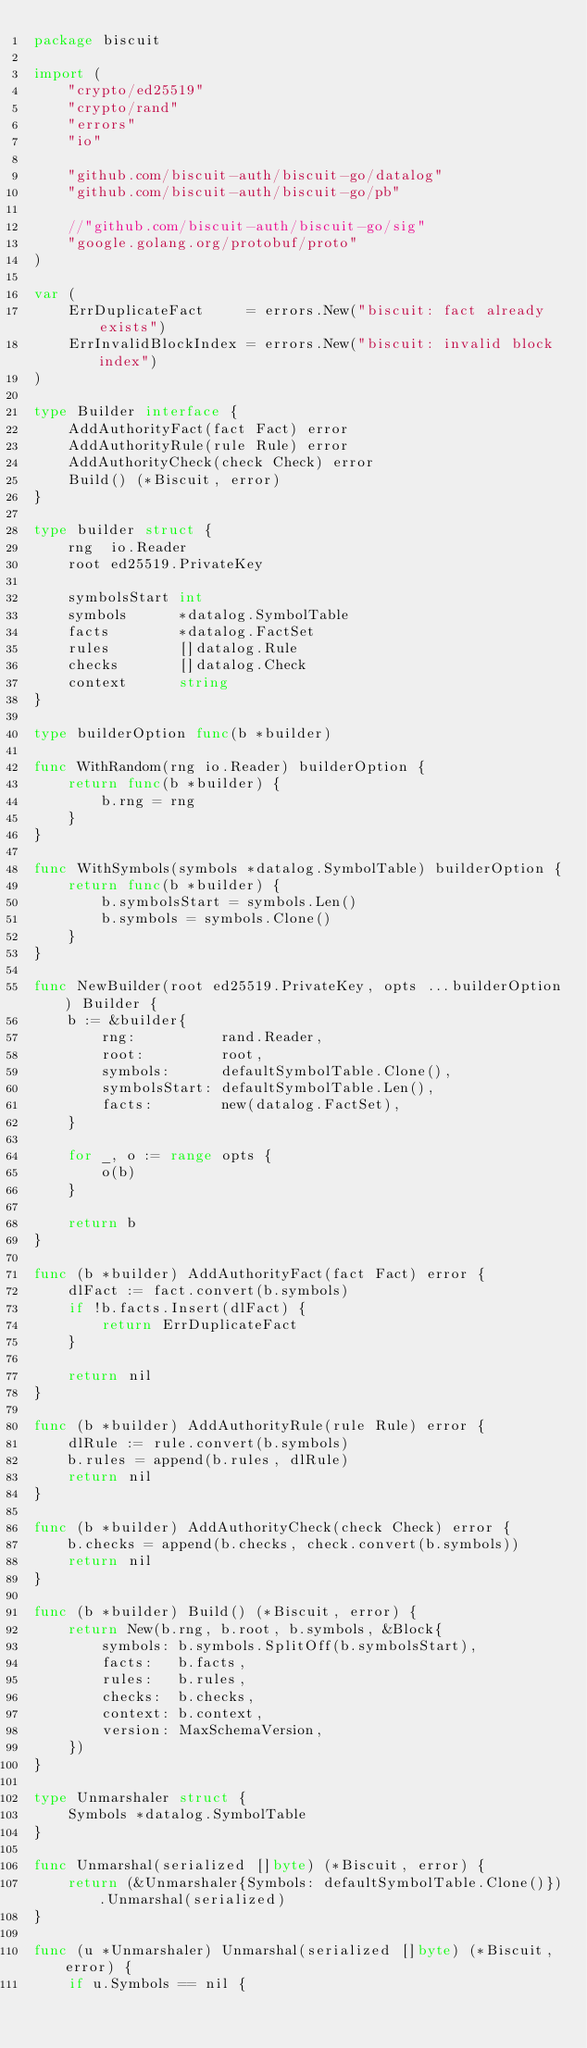<code> <loc_0><loc_0><loc_500><loc_500><_Go_>package biscuit

import (
	"crypto/ed25519"
	"crypto/rand"
	"errors"
	"io"

	"github.com/biscuit-auth/biscuit-go/datalog"
	"github.com/biscuit-auth/biscuit-go/pb"

	//"github.com/biscuit-auth/biscuit-go/sig"
	"google.golang.org/protobuf/proto"
)

var (
	ErrDuplicateFact     = errors.New("biscuit: fact already exists")
	ErrInvalidBlockIndex = errors.New("biscuit: invalid block index")
)

type Builder interface {
	AddAuthorityFact(fact Fact) error
	AddAuthorityRule(rule Rule) error
	AddAuthorityCheck(check Check) error
	Build() (*Biscuit, error)
}

type builder struct {
	rng  io.Reader
	root ed25519.PrivateKey

	symbolsStart int
	symbols      *datalog.SymbolTable
	facts        *datalog.FactSet
	rules        []datalog.Rule
	checks       []datalog.Check
	context      string
}

type builderOption func(b *builder)

func WithRandom(rng io.Reader) builderOption {
	return func(b *builder) {
		b.rng = rng
	}
}

func WithSymbols(symbols *datalog.SymbolTable) builderOption {
	return func(b *builder) {
		b.symbolsStart = symbols.Len()
		b.symbols = symbols.Clone()
	}
}

func NewBuilder(root ed25519.PrivateKey, opts ...builderOption) Builder {
	b := &builder{
		rng:          rand.Reader,
		root:         root,
		symbols:      defaultSymbolTable.Clone(),
		symbolsStart: defaultSymbolTable.Len(),
		facts:        new(datalog.FactSet),
	}

	for _, o := range opts {
		o(b)
	}

	return b
}

func (b *builder) AddAuthorityFact(fact Fact) error {
	dlFact := fact.convert(b.symbols)
	if !b.facts.Insert(dlFact) {
		return ErrDuplicateFact
	}

	return nil
}

func (b *builder) AddAuthorityRule(rule Rule) error {
	dlRule := rule.convert(b.symbols)
	b.rules = append(b.rules, dlRule)
	return nil
}

func (b *builder) AddAuthorityCheck(check Check) error {
	b.checks = append(b.checks, check.convert(b.symbols))
	return nil
}

func (b *builder) Build() (*Biscuit, error) {
	return New(b.rng, b.root, b.symbols, &Block{
		symbols: b.symbols.SplitOff(b.symbolsStart),
		facts:   b.facts,
		rules:   b.rules,
		checks:  b.checks,
		context: b.context,
		version: MaxSchemaVersion,
	})
}

type Unmarshaler struct {
	Symbols *datalog.SymbolTable
}

func Unmarshal(serialized []byte) (*Biscuit, error) {
	return (&Unmarshaler{Symbols: defaultSymbolTable.Clone()}).Unmarshal(serialized)
}

func (u *Unmarshaler) Unmarshal(serialized []byte) (*Biscuit, error) {
	if u.Symbols == nil {</code> 